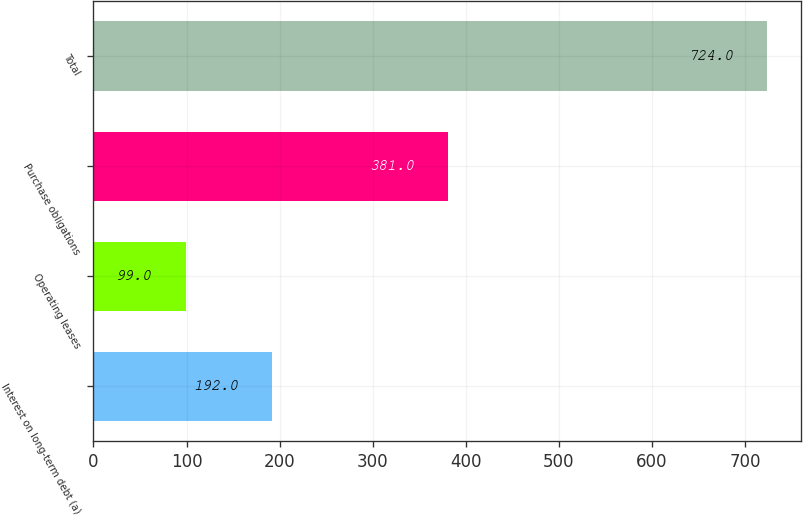<chart> <loc_0><loc_0><loc_500><loc_500><bar_chart><fcel>Interest on long-term debt (a)<fcel>Operating leases<fcel>Purchase obligations<fcel>Total<nl><fcel>192<fcel>99<fcel>381<fcel>724<nl></chart> 